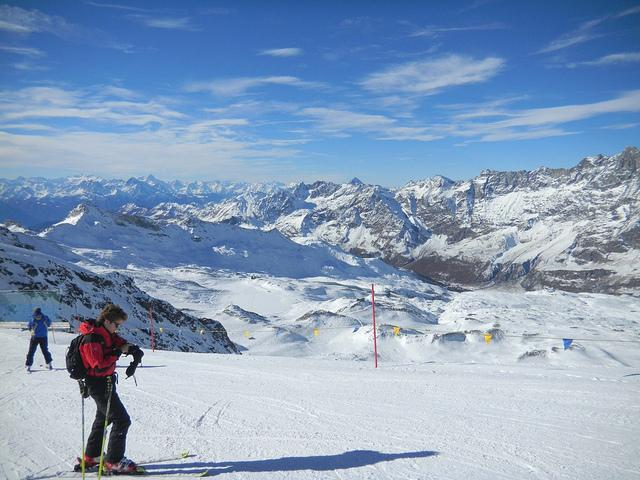Where is the sun with respect to the person wearing red coat? left 